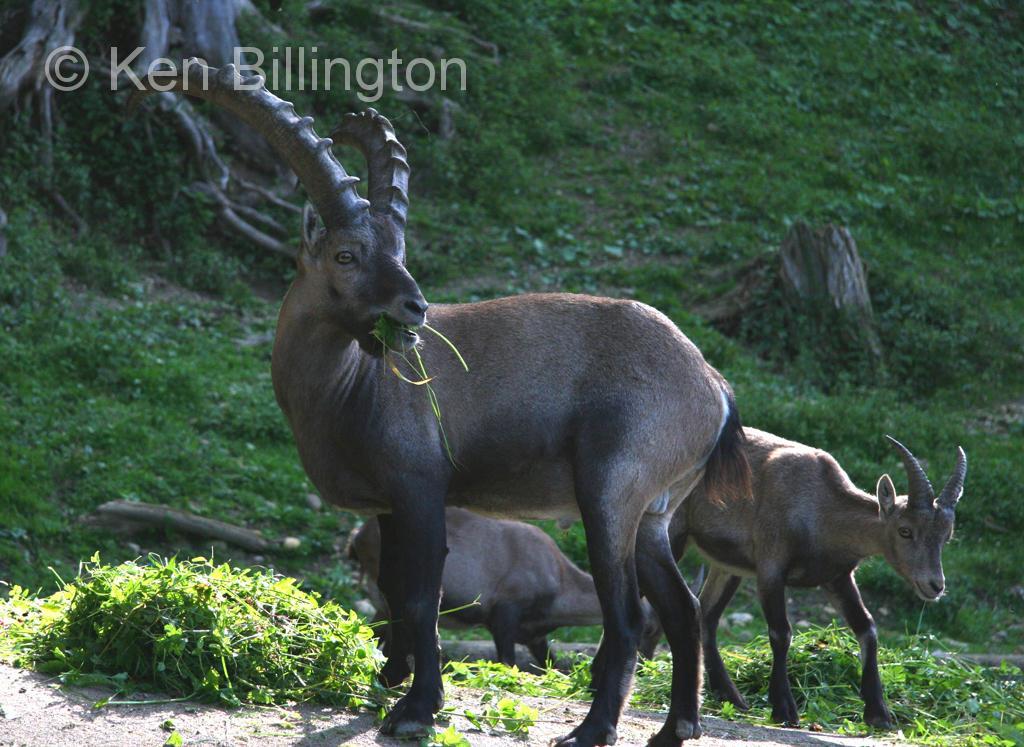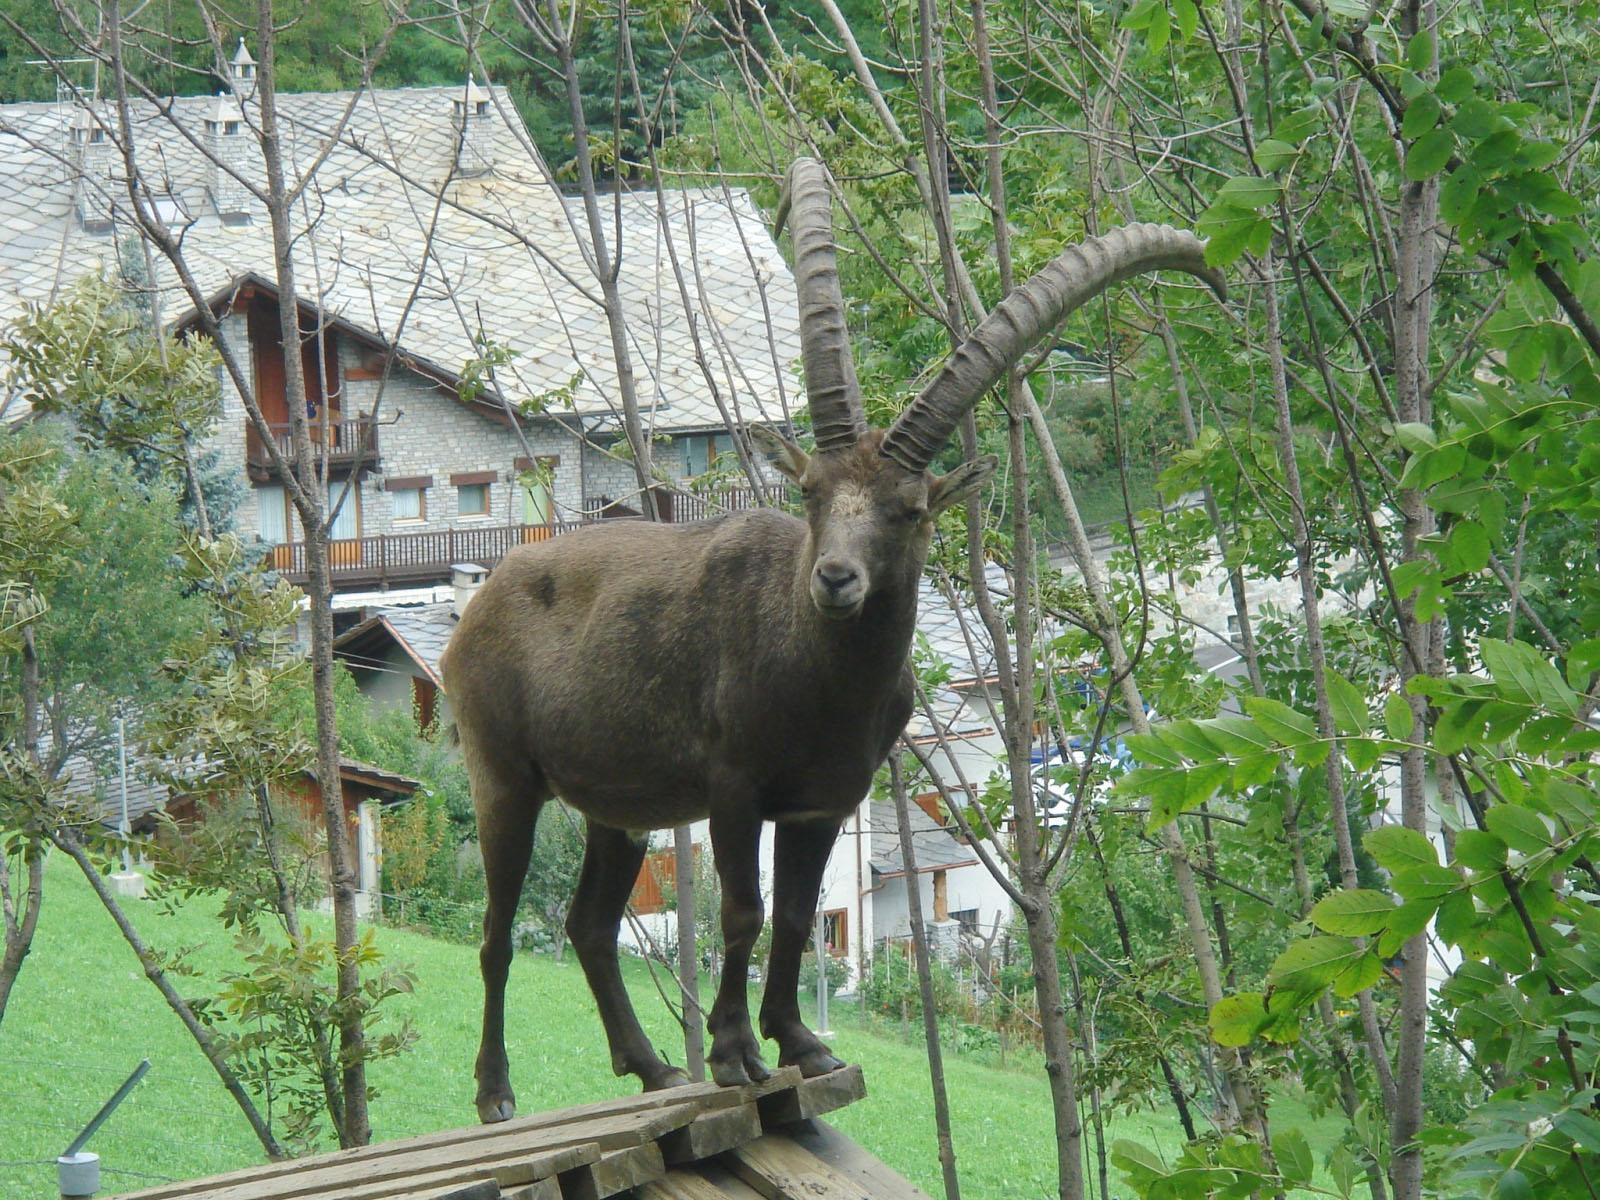The first image is the image on the left, the second image is the image on the right. For the images shown, is this caption "The large ram is standing near small rams in one of the images." true? Answer yes or no. Yes. The first image is the image on the left, the second image is the image on the right. Examine the images to the left and right. Is the description "The left and right image contains the same number of goats." accurate? Answer yes or no. No. 